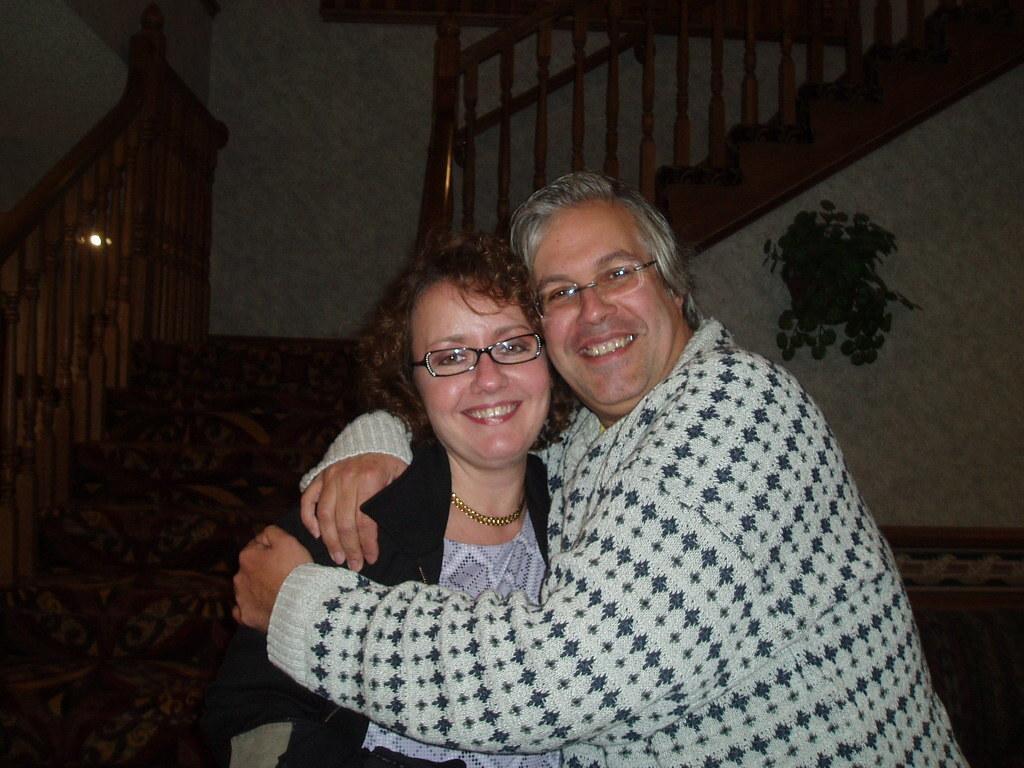Describe this image in one or two sentences. This picture is clicked inside the room. In this picture, we see the man and the women are smiling. Both of them are wearing the spectacles and they are posing for the photo. Behind them, we see the staircase and the stair railing. In the background, we see a white wall. This picture might be clicked in the dark. 